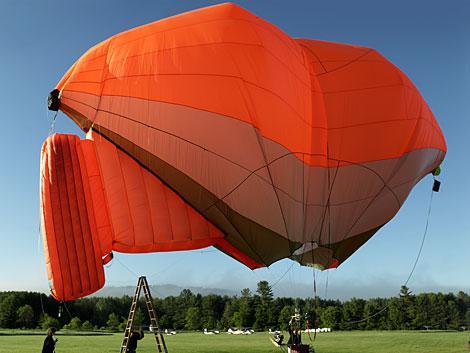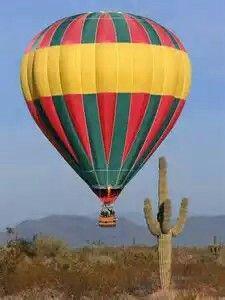The first image is the image on the left, the second image is the image on the right. Examine the images to the left and right. Is the description "One of the balloons has a face depicted on it." accurate? Answer yes or no. No. 